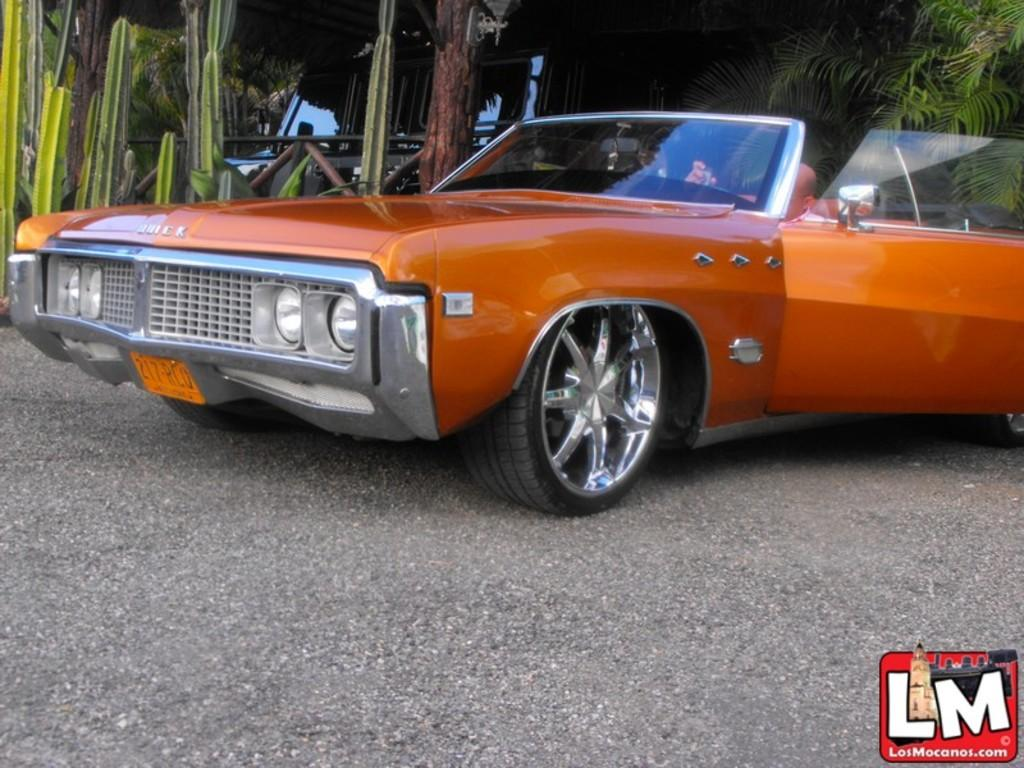What can be seen on the ground in the image? There are vehicles parked on the ground in the image. What is located on the left side of the image? There are plants on the left side of the image. What object can be seen in the background of the image? There is a lamp visible in the background of the image. What type of vegetation is visible in the background of the image? There are trees present in the background of the image. What is the name of the person who regrets parking their vehicle in the image? There is no information about the person who parked the vehicle or their feelings in the image. What is the reason for the trees being present in the background of the image? The image does not provide any information about the reason for the trees being present in the background. 